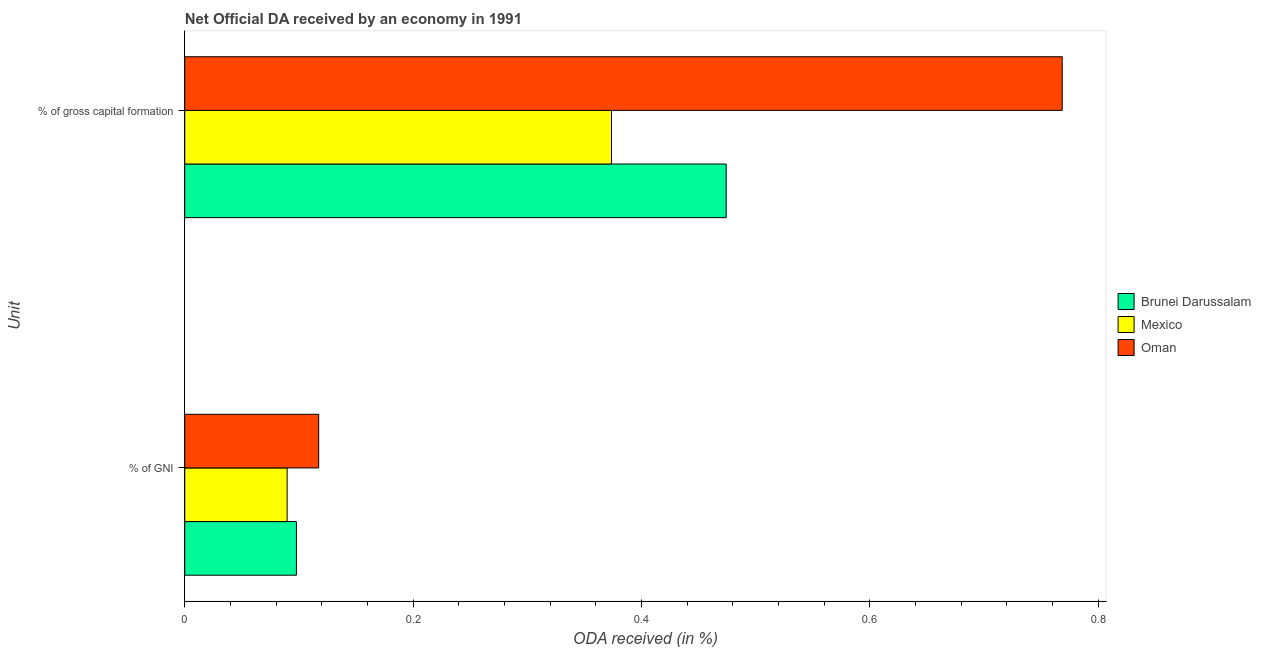How many different coloured bars are there?
Make the answer very short. 3. What is the label of the 1st group of bars from the top?
Offer a terse response. % of gross capital formation. What is the oda received as percentage of gross capital formation in Mexico?
Offer a terse response. 0.37. Across all countries, what is the maximum oda received as percentage of gni?
Offer a very short reply. 0.12. Across all countries, what is the minimum oda received as percentage of gross capital formation?
Your answer should be compact. 0.37. In which country was the oda received as percentage of gross capital formation maximum?
Your answer should be very brief. Oman. What is the total oda received as percentage of gross capital formation in the graph?
Give a very brief answer. 1.62. What is the difference between the oda received as percentage of gross capital formation in Brunei Darussalam and that in Mexico?
Your answer should be compact. 0.1. What is the difference between the oda received as percentage of gross capital formation in Brunei Darussalam and the oda received as percentage of gni in Oman?
Provide a succinct answer. 0.36. What is the average oda received as percentage of gni per country?
Your answer should be very brief. 0.1. What is the difference between the oda received as percentage of gross capital formation and oda received as percentage of gni in Mexico?
Offer a very short reply. 0.28. In how many countries, is the oda received as percentage of gross capital formation greater than 0.04 %?
Provide a succinct answer. 3. What is the ratio of the oda received as percentage of gni in Oman to that in Mexico?
Give a very brief answer. 1.31. Is the oda received as percentage of gni in Oman less than that in Mexico?
Provide a succinct answer. No. Are all the bars in the graph horizontal?
Offer a terse response. Yes. Where does the legend appear in the graph?
Provide a short and direct response. Center right. How many legend labels are there?
Give a very brief answer. 3. What is the title of the graph?
Your answer should be compact. Net Official DA received by an economy in 1991. Does "Palau" appear as one of the legend labels in the graph?
Your answer should be very brief. No. What is the label or title of the X-axis?
Keep it short and to the point. ODA received (in %). What is the label or title of the Y-axis?
Make the answer very short. Unit. What is the ODA received (in %) of Brunei Darussalam in % of GNI?
Offer a terse response. 0.1. What is the ODA received (in %) in Mexico in % of GNI?
Ensure brevity in your answer.  0.09. What is the ODA received (in %) of Oman in % of GNI?
Your response must be concise. 0.12. What is the ODA received (in %) in Brunei Darussalam in % of gross capital formation?
Your answer should be very brief. 0.47. What is the ODA received (in %) in Mexico in % of gross capital formation?
Ensure brevity in your answer.  0.37. What is the ODA received (in %) in Oman in % of gross capital formation?
Offer a terse response. 0.77. Across all Unit, what is the maximum ODA received (in %) of Brunei Darussalam?
Provide a short and direct response. 0.47. Across all Unit, what is the maximum ODA received (in %) of Mexico?
Your answer should be compact. 0.37. Across all Unit, what is the maximum ODA received (in %) of Oman?
Provide a short and direct response. 0.77. Across all Unit, what is the minimum ODA received (in %) in Brunei Darussalam?
Ensure brevity in your answer.  0.1. Across all Unit, what is the minimum ODA received (in %) in Mexico?
Give a very brief answer. 0.09. Across all Unit, what is the minimum ODA received (in %) of Oman?
Ensure brevity in your answer.  0.12. What is the total ODA received (in %) in Brunei Darussalam in the graph?
Your answer should be compact. 0.57. What is the total ODA received (in %) of Mexico in the graph?
Keep it short and to the point. 0.46. What is the total ODA received (in %) of Oman in the graph?
Your answer should be very brief. 0.89. What is the difference between the ODA received (in %) in Brunei Darussalam in % of GNI and that in % of gross capital formation?
Give a very brief answer. -0.38. What is the difference between the ODA received (in %) in Mexico in % of GNI and that in % of gross capital formation?
Provide a short and direct response. -0.28. What is the difference between the ODA received (in %) of Oman in % of GNI and that in % of gross capital formation?
Ensure brevity in your answer.  -0.65. What is the difference between the ODA received (in %) in Brunei Darussalam in % of GNI and the ODA received (in %) in Mexico in % of gross capital formation?
Your answer should be very brief. -0.28. What is the difference between the ODA received (in %) in Brunei Darussalam in % of GNI and the ODA received (in %) in Oman in % of gross capital formation?
Make the answer very short. -0.67. What is the difference between the ODA received (in %) in Mexico in % of GNI and the ODA received (in %) in Oman in % of gross capital formation?
Provide a succinct answer. -0.68. What is the average ODA received (in %) in Brunei Darussalam per Unit?
Provide a succinct answer. 0.29. What is the average ODA received (in %) of Mexico per Unit?
Your response must be concise. 0.23. What is the average ODA received (in %) in Oman per Unit?
Provide a short and direct response. 0.44. What is the difference between the ODA received (in %) in Brunei Darussalam and ODA received (in %) in Mexico in % of GNI?
Give a very brief answer. 0.01. What is the difference between the ODA received (in %) of Brunei Darussalam and ODA received (in %) of Oman in % of GNI?
Make the answer very short. -0.02. What is the difference between the ODA received (in %) in Mexico and ODA received (in %) in Oman in % of GNI?
Provide a short and direct response. -0.03. What is the difference between the ODA received (in %) in Brunei Darussalam and ODA received (in %) in Mexico in % of gross capital formation?
Your answer should be very brief. 0.1. What is the difference between the ODA received (in %) in Brunei Darussalam and ODA received (in %) in Oman in % of gross capital formation?
Your answer should be compact. -0.29. What is the difference between the ODA received (in %) in Mexico and ODA received (in %) in Oman in % of gross capital formation?
Your response must be concise. -0.39. What is the ratio of the ODA received (in %) in Brunei Darussalam in % of GNI to that in % of gross capital formation?
Offer a terse response. 0.21. What is the ratio of the ODA received (in %) of Mexico in % of GNI to that in % of gross capital formation?
Your answer should be very brief. 0.24. What is the ratio of the ODA received (in %) in Oman in % of GNI to that in % of gross capital formation?
Give a very brief answer. 0.15. What is the difference between the highest and the second highest ODA received (in %) of Brunei Darussalam?
Make the answer very short. 0.38. What is the difference between the highest and the second highest ODA received (in %) of Mexico?
Give a very brief answer. 0.28. What is the difference between the highest and the second highest ODA received (in %) in Oman?
Ensure brevity in your answer.  0.65. What is the difference between the highest and the lowest ODA received (in %) in Brunei Darussalam?
Your response must be concise. 0.38. What is the difference between the highest and the lowest ODA received (in %) in Mexico?
Keep it short and to the point. 0.28. What is the difference between the highest and the lowest ODA received (in %) in Oman?
Keep it short and to the point. 0.65. 